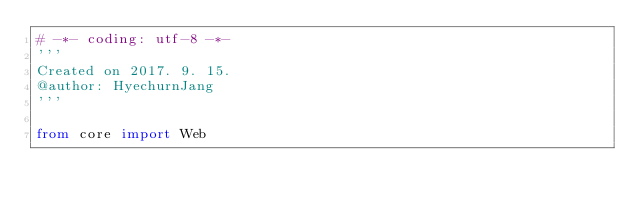<code> <loc_0><loc_0><loc_500><loc_500><_Python_># -*- coding: utf-8 -*-
'''
Created on 2017. 9. 15.
@author: HyechurnJang
'''

from core import Web
</code> 